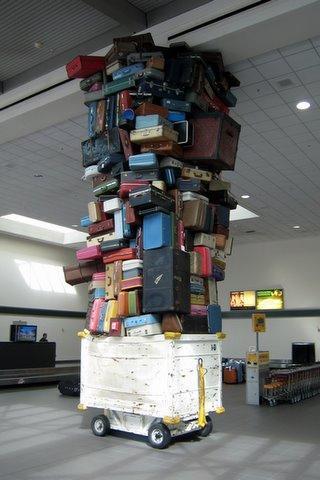How many suitcases are in the picture?
Give a very brief answer. 2. How many beds are in the picture?
Give a very brief answer. 0. 